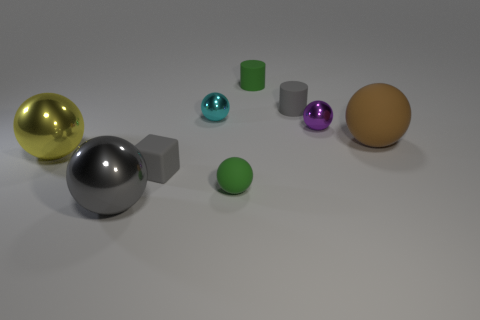Subtract all green balls. How many balls are left? 5 Subtract all green spheres. How many spheres are left? 5 Subtract all brown balls. Subtract all blue blocks. How many balls are left? 5 Subtract all cylinders. How many objects are left? 7 Add 7 small green matte cylinders. How many small green matte cylinders exist? 8 Subtract 0 blue cylinders. How many objects are left? 9 Subtract all small yellow rubber blocks. Subtract all cyan spheres. How many objects are left? 8 Add 4 gray cubes. How many gray cubes are left? 5 